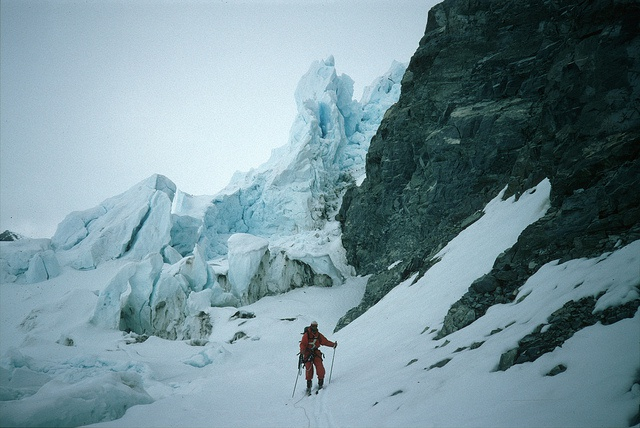Describe the objects in this image and their specific colors. I can see people in gray, black, maroon, and darkgray tones, skis in gray, black, and purple tones, and backpack in gray, black, lightblue, and teal tones in this image. 